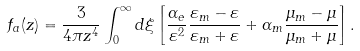Convert formula to latex. <formula><loc_0><loc_0><loc_500><loc_500>f _ { a } ( z ) = \frac { 3 } { 4 \pi z ^ { 4 } } \int _ { 0 } ^ { \infty } d \xi \left [ \frac { \alpha _ { e } } { \varepsilon ^ { 2 } } \frac { \varepsilon _ { m } - \varepsilon } { \varepsilon _ { m } + \varepsilon } + \alpha _ { m } \frac { \mu _ { m } - \mu } { \mu _ { m } + \mu } \right ] .</formula> 